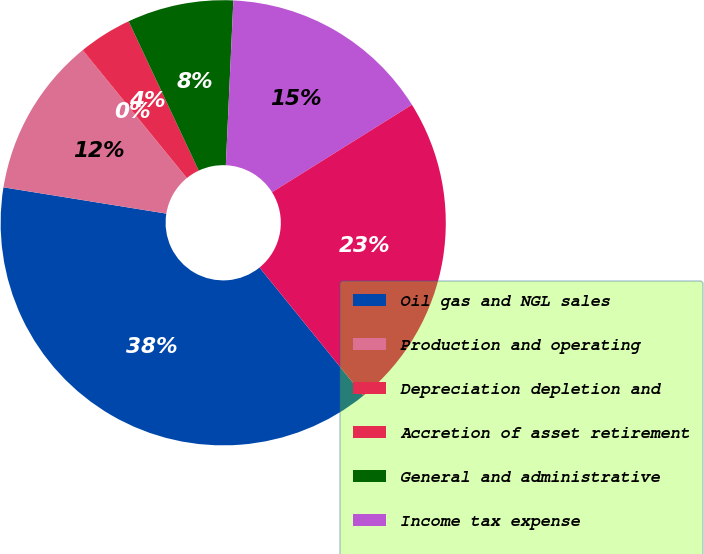Convert chart to OTSL. <chart><loc_0><loc_0><loc_500><loc_500><pie_chart><fcel>Oil gas and NGL sales<fcel>Production and operating<fcel>Depreciation depletion and<fcel>Accretion of asset retirement<fcel>General and administrative<fcel>Income tax expense<fcel>Results of operations<nl><fcel>38.39%<fcel>11.55%<fcel>0.04%<fcel>3.88%<fcel>7.71%<fcel>15.38%<fcel>23.05%<nl></chart> 